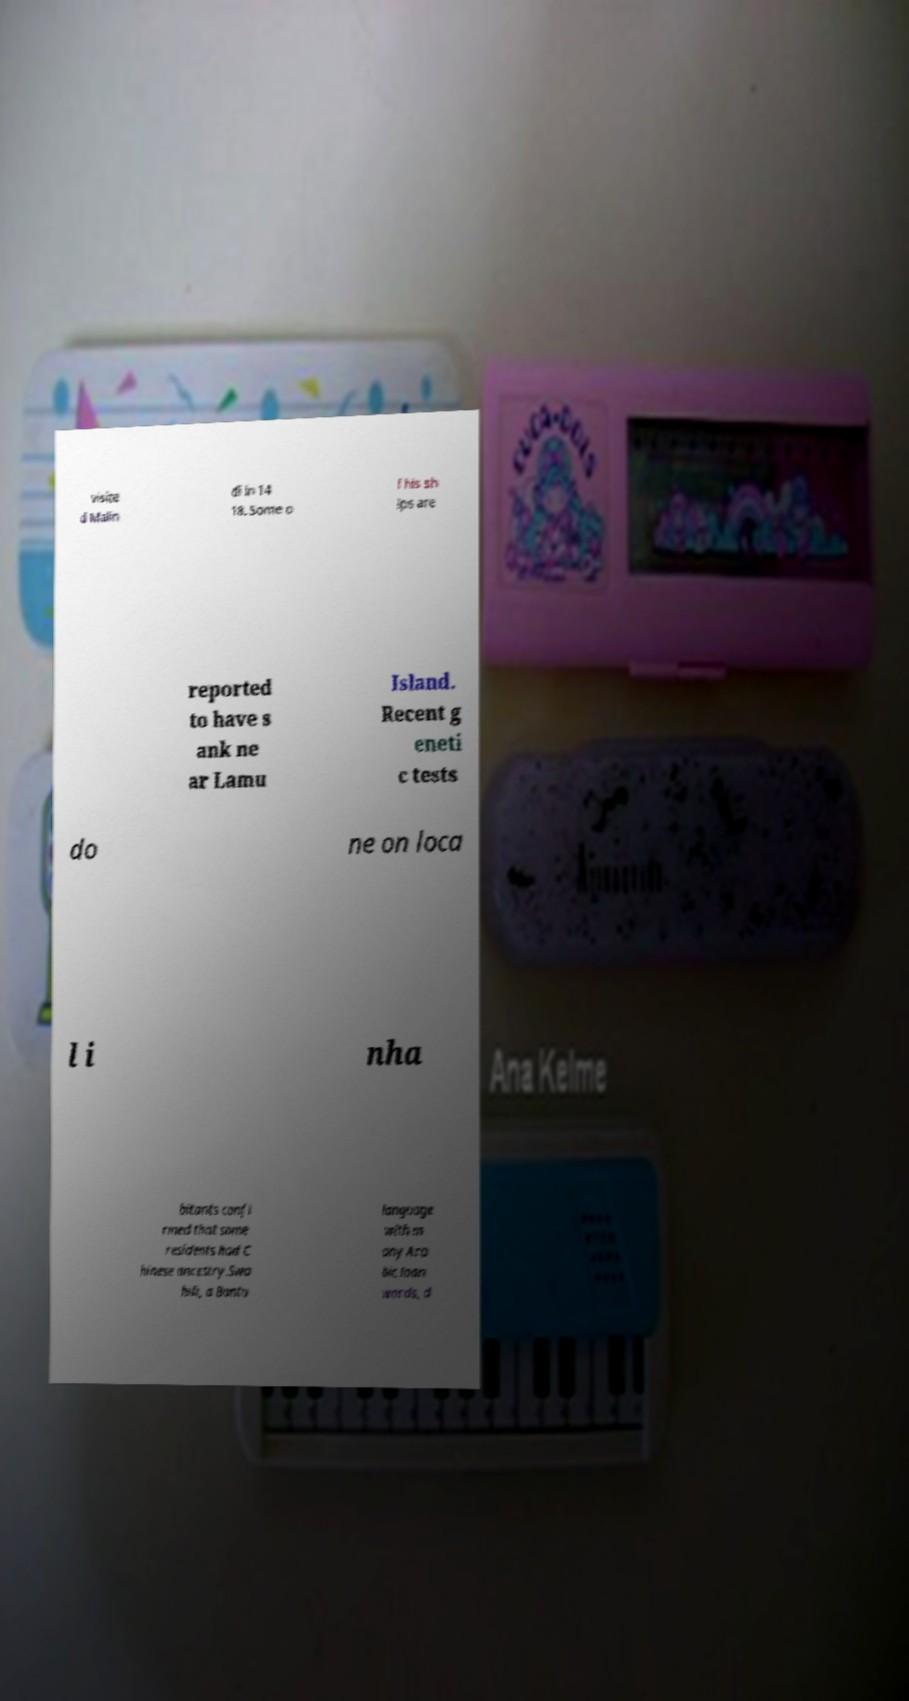Can you read and provide the text displayed in the image?This photo seems to have some interesting text. Can you extract and type it out for me? visite d Malin di in 14 18. Some o f his sh ips are reported to have s ank ne ar Lamu Island. Recent g eneti c tests do ne on loca l i nha bitants confi rmed that some residents had C hinese ancestry.Swa hili, a Bantu language with m any Ara bic loan words, d 